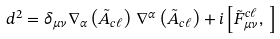Convert formula to latex. <formula><loc_0><loc_0><loc_500><loc_500>d ^ { 2 } = \delta _ { \mu \nu } \nabla _ { \alpha } \left ( \tilde { A } _ { c \ell } \right ) \, \nabla ^ { \alpha } \left ( \tilde { A } _ { c \ell } \right ) + i \left [ \tilde { F } _ { \mu \nu } ^ { c \ell } , \, \right ]</formula> 